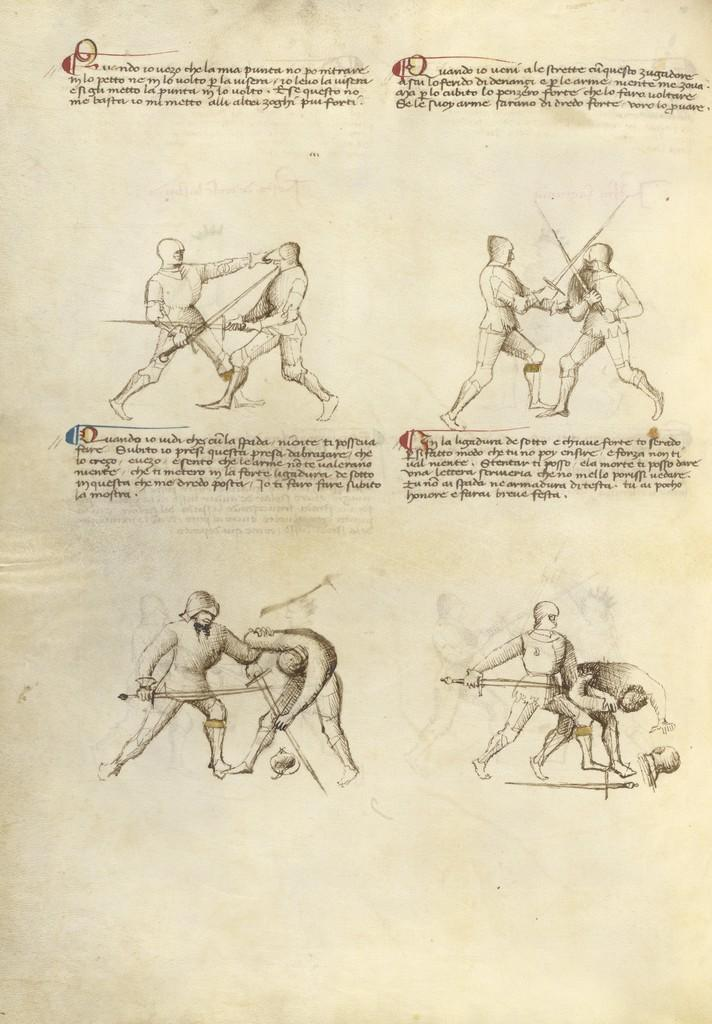What are the people in the image holding? The people in the image are holding knives. What else can be seen in the image besides the people holding knives? There is a paper with writing on it in the image. What type of downtown apparatus can be seen in the image? There is no downtown apparatus present in the image. 